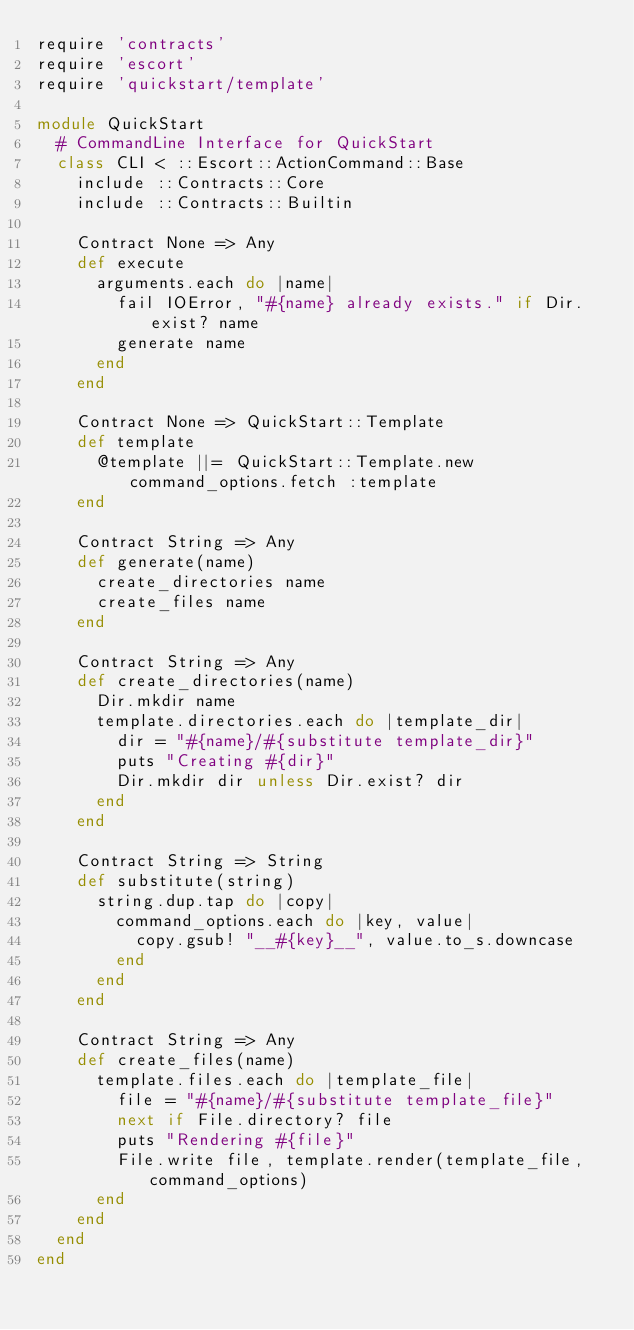Convert code to text. <code><loc_0><loc_0><loc_500><loc_500><_Ruby_>require 'contracts'
require 'escort'
require 'quickstart/template'

module QuickStart
  # CommandLine Interface for QuickStart
  class CLI < ::Escort::ActionCommand::Base
    include ::Contracts::Core
    include ::Contracts::Builtin

    Contract None => Any
    def execute
      arguments.each do |name|
        fail IOError, "#{name} already exists." if Dir.exist? name
        generate name
      end
    end

    Contract None => QuickStart::Template
    def template
      @template ||= QuickStart::Template.new command_options.fetch :template
    end

    Contract String => Any
    def generate(name)
      create_directories name
      create_files name
    end

    Contract String => Any
    def create_directories(name)
      Dir.mkdir name
      template.directories.each do |template_dir|
        dir = "#{name}/#{substitute template_dir}"
        puts "Creating #{dir}"
        Dir.mkdir dir unless Dir.exist? dir
      end
    end

    Contract String => String
    def substitute(string)
      string.dup.tap do |copy|
        command_options.each do |key, value|
          copy.gsub! "__#{key}__", value.to_s.downcase
        end
      end
    end

    Contract String => Any
    def create_files(name)
      template.files.each do |template_file|
        file = "#{name}/#{substitute template_file}"
        next if File.directory? file
        puts "Rendering #{file}"
        File.write file, template.render(template_file, command_options)
      end
    end
  end
end
</code> 